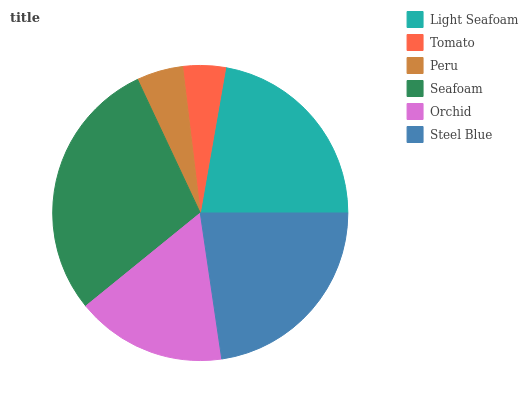Is Tomato the minimum?
Answer yes or no. Yes. Is Seafoam the maximum?
Answer yes or no. Yes. Is Peru the minimum?
Answer yes or no. No. Is Peru the maximum?
Answer yes or no. No. Is Peru greater than Tomato?
Answer yes or no. Yes. Is Tomato less than Peru?
Answer yes or no. Yes. Is Tomato greater than Peru?
Answer yes or no. No. Is Peru less than Tomato?
Answer yes or no. No. Is Light Seafoam the high median?
Answer yes or no. Yes. Is Orchid the low median?
Answer yes or no. Yes. Is Peru the high median?
Answer yes or no. No. Is Tomato the low median?
Answer yes or no. No. 